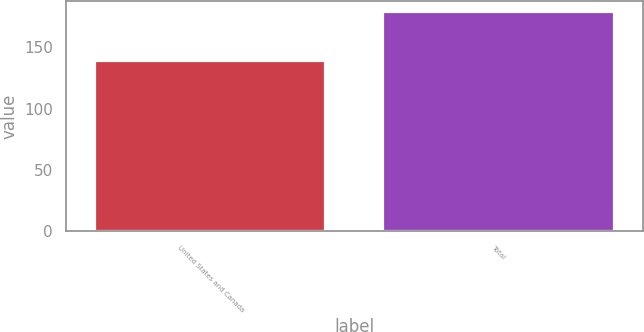<chart> <loc_0><loc_0><loc_500><loc_500><bar_chart><fcel>United States and Canada<fcel>Total<nl><fcel>139<fcel>179<nl></chart> 